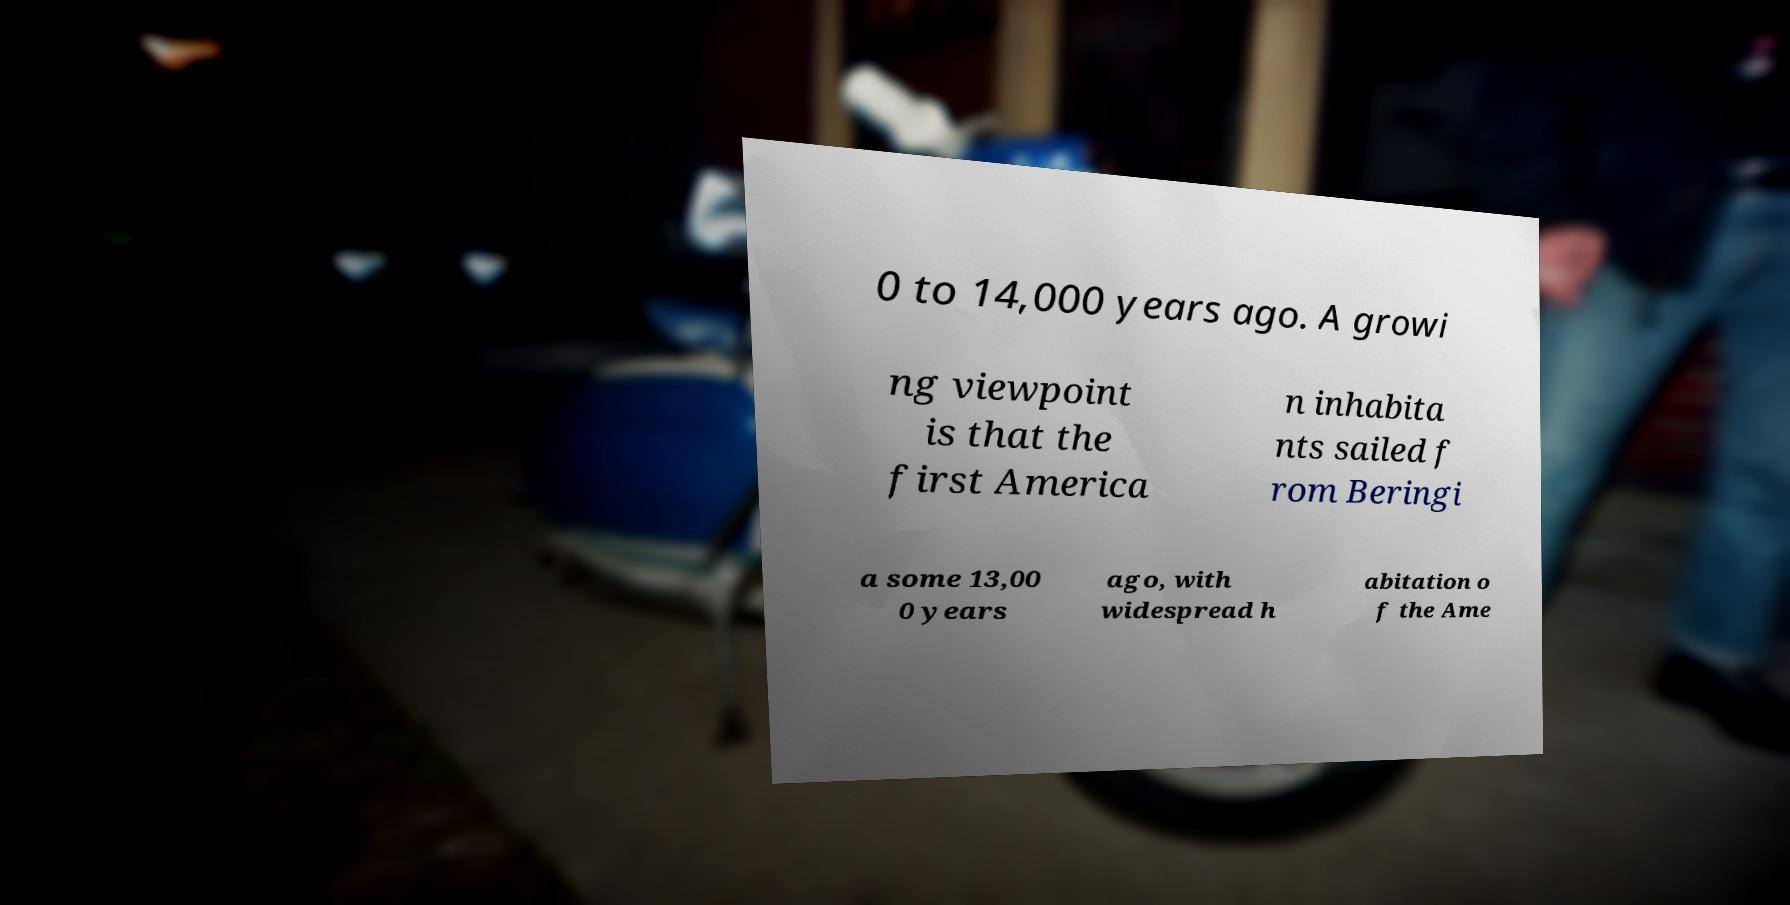What messages or text are displayed in this image? I need them in a readable, typed format. 0 to 14,000 years ago. A growi ng viewpoint is that the first America n inhabita nts sailed f rom Beringi a some 13,00 0 years ago, with widespread h abitation o f the Ame 